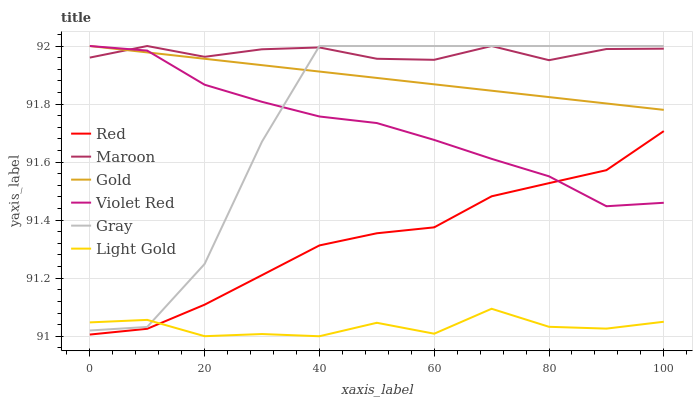Does Light Gold have the minimum area under the curve?
Answer yes or no. Yes. Does Maroon have the maximum area under the curve?
Answer yes or no. Yes. Does Violet Red have the minimum area under the curve?
Answer yes or no. No. Does Violet Red have the maximum area under the curve?
Answer yes or no. No. Is Gold the smoothest?
Answer yes or no. Yes. Is Gray the roughest?
Answer yes or no. Yes. Is Violet Red the smoothest?
Answer yes or no. No. Is Violet Red the roughest?
Answer yes or no. No. Does Light Gold have the lowest value?
Answer yes or no. Yes. Does Violet Red have the lowest value?
Answer yes or no. No. Does Maroon have the highest value?
Answer yes or no. Yes. Does Light Gold have the highest value?
Answer yes or no. No. Is Red less than Gray?
Answer yes or no. Yes. Is Gold greater than Light Gold?
Answer yes or no. Yes. Does Gold intersect Gray?
Answer yes or no. Yes. Is Gold less than Gray?
Answer yes or no. No. Is Gold greater than Gray?
Answer yes or no. No. Does Red intersect Gray?
Answer yes or no. No. 